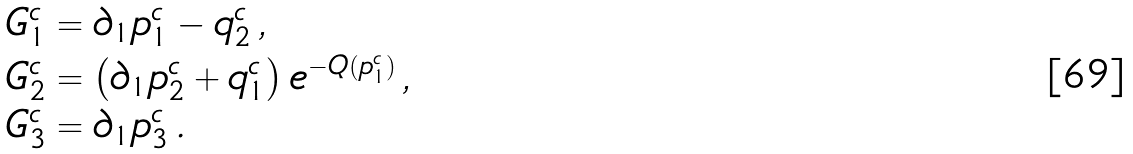<formula> <loc_0><loc_0><loc_500><loc_500>& G _ { 1 } ^ { c } = \partial _ { 1 } p _ { 1 } ^ { c } - q _ { 2 } ^ { c } \, , \\ & G _ { 2 } ^ { c } = \left ( \partial _ { 1 } p _ { 2 } ^ { c } + q _ { 1 } ^ { c } \right ) e ^ { - Q ( p _ { 1 } ^ { c } ) } \, , \\ & G _ { 3 } ^ { c } = \partial _ { 1 } p _ { 3 } ^ { c } \, .</formula> 